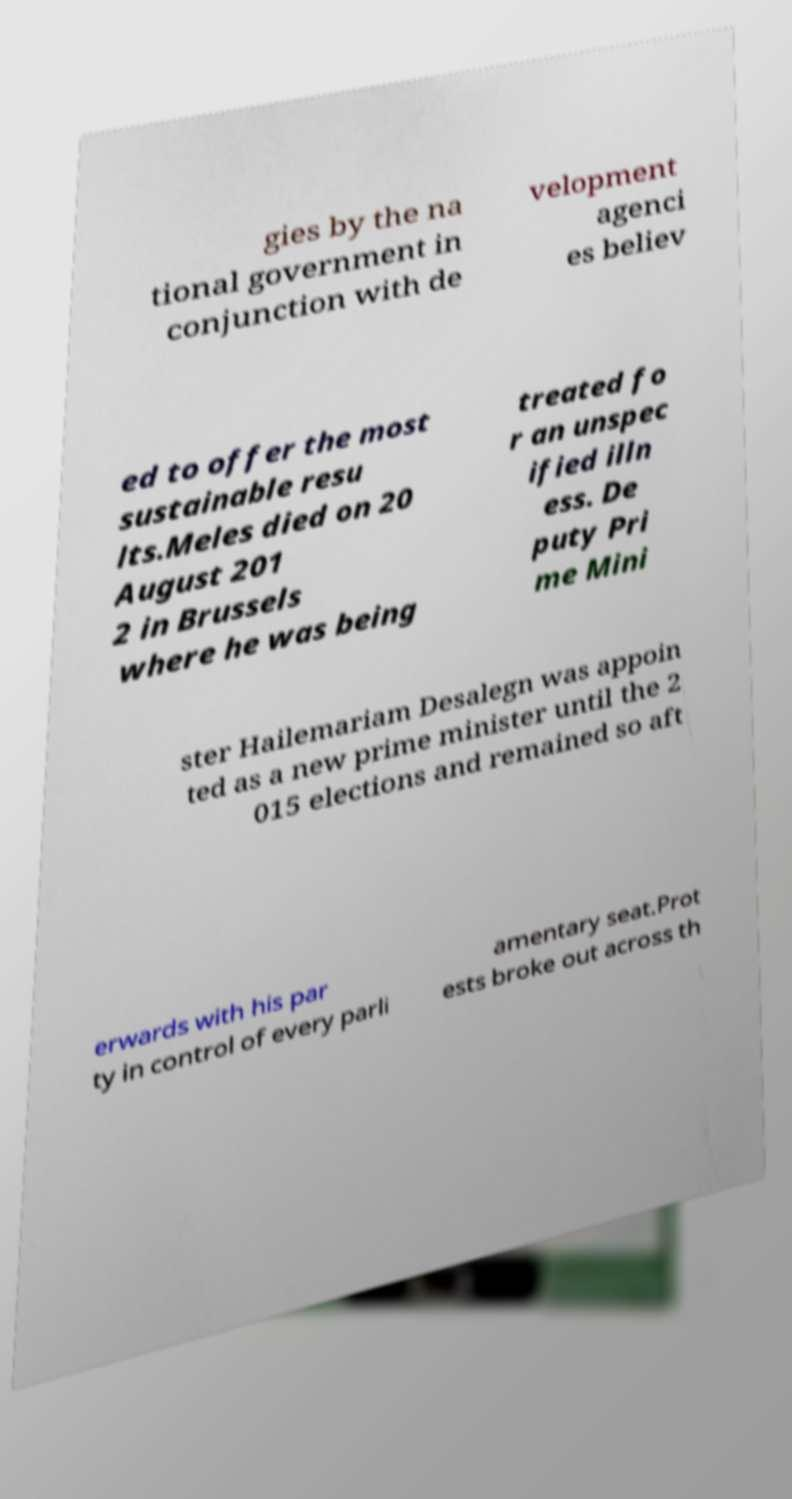Could you assist in decoding the text presented in this image and type it out clearly? gies by the na tional government in conjunction with de velopment agenci es believ ed to offer the most sustainable resu lts.Meles died on 20 August 201 2 in Brussels where he was being treated fo r an unspec ified illn ess. De puty Pri me Mini ster Hailemariam Desalegn was appoin ted as a new prime minister until the 2 015 elections and remained so aft erwards with his par ty in control of every parli amentary seat.Prot ests broke out across th 